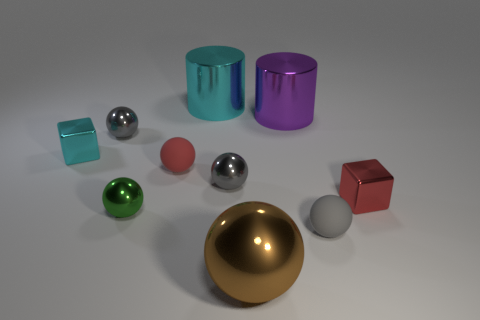Are any small brown balls visible?
Make the answer very short. No. What size is the cyan cube that is the same material as the green thing?
Your answer should be compact. Small. What shape is the gray object in front of the shiny block that is in front of the small shiny block that is left of the big cyan metal cylinder?
Your answer should be compact. Sphere. Are there an equal number of metallic cubes that are in front of the small cyan shiny cube and tiny red shiny cubes?
Keep it short and to the point. Yes. Is the shape of the large purple object the same as the large cyan metal thing?
Ensure brevity in your answer.  Yes. What number of objects are either metallic cubes that are to the right of the tiny cyan cube or matte spheres?
Ensure brevity in your answer.  3. Are there an equal number of brown balls that are behind the green shiny ball and matte objects on the left side of the large cyan metal object?
Give a very brief answer. No. How many other things are the same shape as the large brown metallic thing?
Give a very brief answer. 5. There is a cube on the left side of the large brown thing; does it have the same size as the purple thing on the right side of the cyan metal cylinder?
Provide a succinct answer. No. What number of cylinders are metal objects or tiny gray things?
Ensure brevity in your answer.  2. 